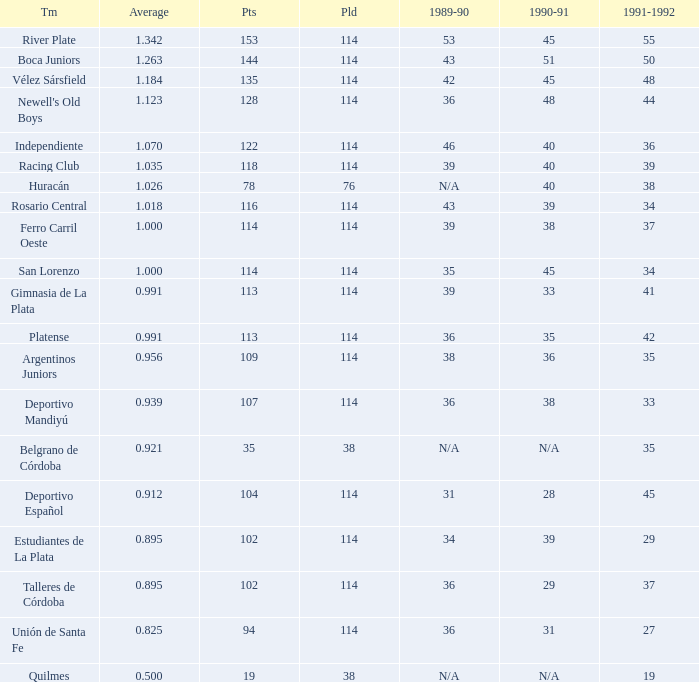How much Played has an Average smaller than 0.9390000000000001, and a 1990-91 of 28? 1.0. 